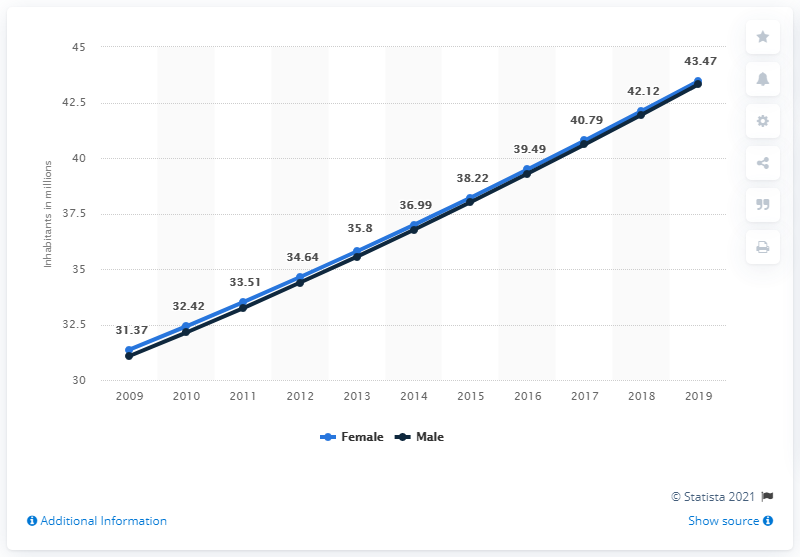Highlight a few significant elements in this photo. In 2019, the female population of the Democratic Republic of the Congo was estimated to be approximately 43.47 million. 